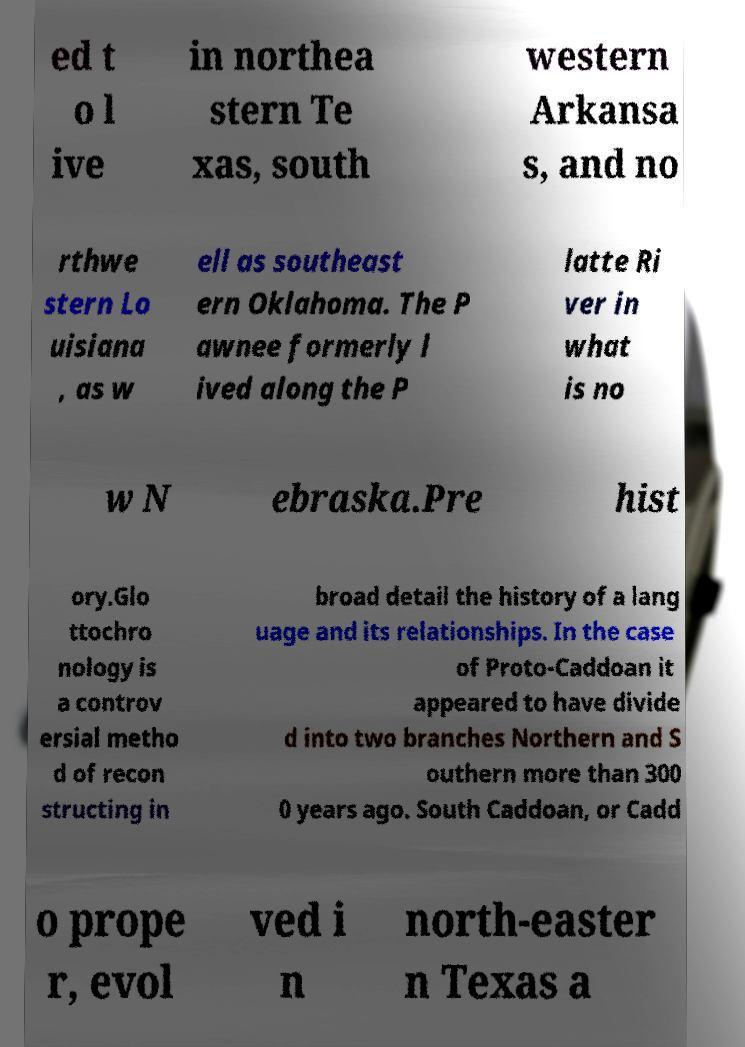I need the written content from this picture converted into text. Can you do that? ed t o l ive in northea stern Te xas, south western Arkansa s, and no rthwe stern Lo uisiana , as w ell as southeast ern Oklahoma. The P awnee formerly l ived along the P latte Ri ver in what is no w N ebraska.Pre hist ory.Glo ttochro nology is a controv ersial metho d of recon structing in broad detail the history of a lang uage and its relationships. In the case of Proto-Caddoan it appeared to have divide d into two branches Northern and S outhern more than 300 0 years ago. South Caddoan, or Cadd o prope r, evol ved i n north-easter n Texas a 